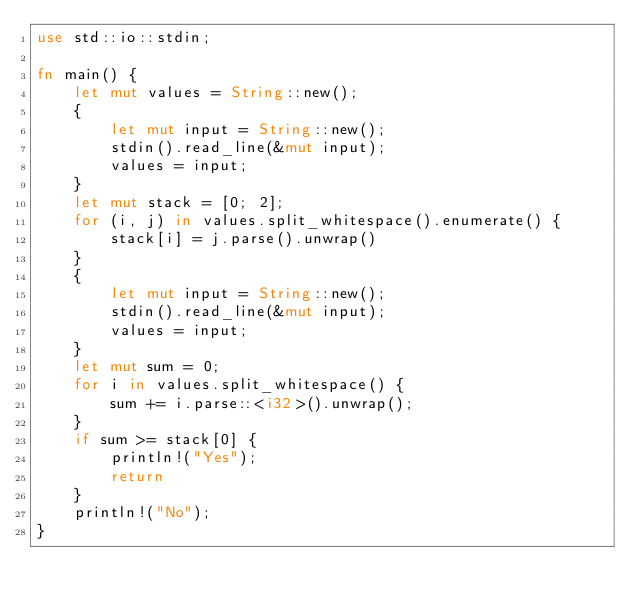<code> <loc_0><loc_0><loc_500><loc_500><_Rust_>use std::io::stdin;

fn main() {
    let mut values = String::new();
    {
        let mut input = String::new();
        stdin().read_line(&mut input);
        values = input;
    }
    let mut stack = [0; 2];
    for (i, j) in values.split_whitespace().enumerate() {
        stack[i] = j.parse().unwrap()
    }
    {
        let mut input = String::new();
        stdin().read_line(&mut input);
        values = input;
    }
    let mut sum = 0;
    for i in values.split_whitespace() {
        sum += i.parse::<i32>().unwrap();
    }
    if sum >= stack[0] {
        println!("Yes");
        return
    }
    println!("No");
}</code> 